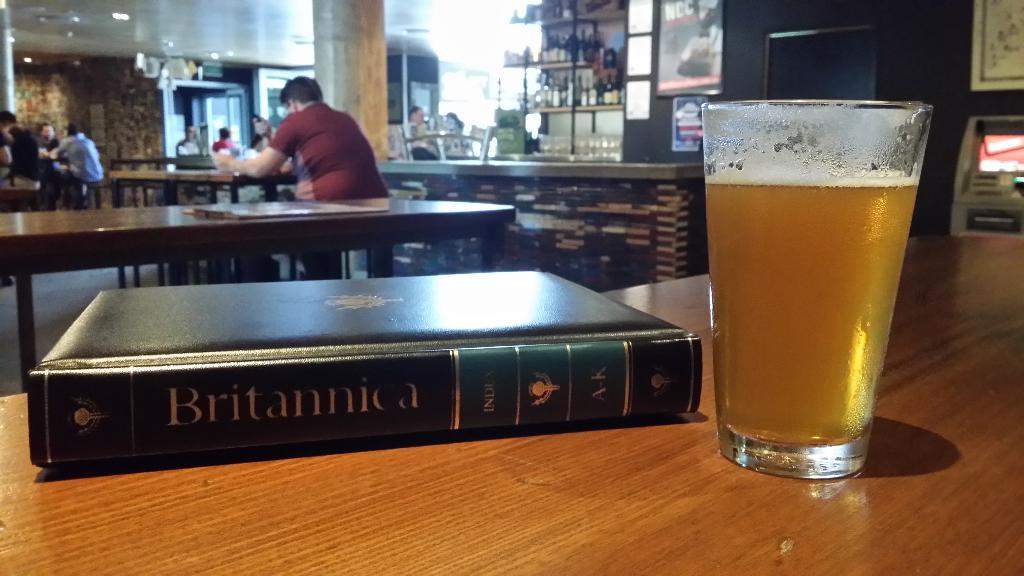<image>
Offer a succinct explanation of the picture presented. A volume of the Encyclopedia Britannica next to a glass of beer on a wooden table. 